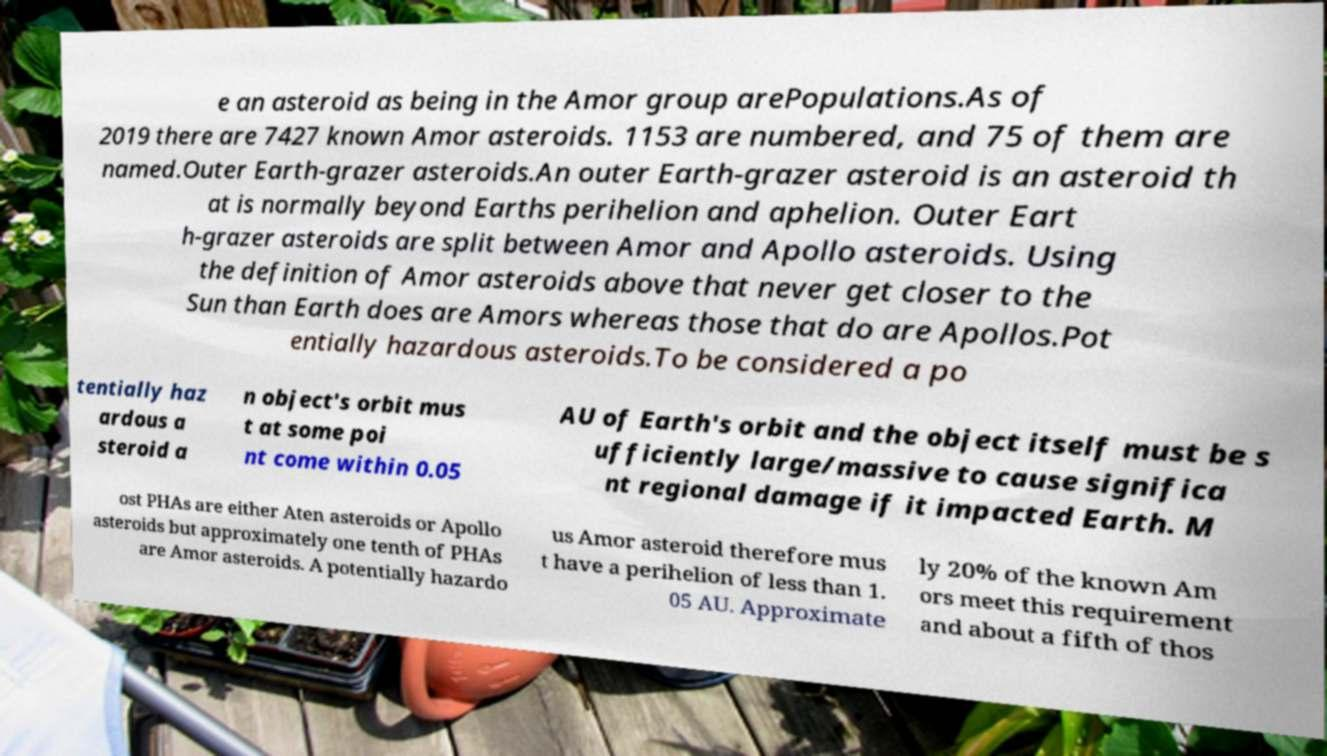Could you extract and type out the text from this image? e an asteroid as being in the Amor group arePopulations.As of 2019 there are 7427 known Amor asteroids. 1153 are numbered, and 75 of them are named.Outer Earth-grazer asteroids.An outer Earth-grazer asteroid is an asteroid th at is normally beyond Earths perihelion and aphelion. Outer Eart h-grazer asteroids are split between Amor and Apollo asteroids. Using the definition of Amor asteroids above that never get closer to the Sun than Earth does are Amors whereas those that do are Apollos.Pot entially hazardous asteroids.To be considered a po tentially haz ardous a steroid a n object's orbit mus t at some poi nt come within 0.05 AU of Earth's orbit and the object itself must be s ufficiently large/massive to cause significa nt regional damage if it impacted Earth. M ost PHAs are either Aten asteroids or Apollo asteroids but approximately one tenth of PHAs are Amor asteroids. A potentially hazardo us Amor asteroid therefore mus t have a perihelion of less than 1. 05 AU. Approximate ly 20% of the known Am ors meet this requirement and about a fifth of thos 